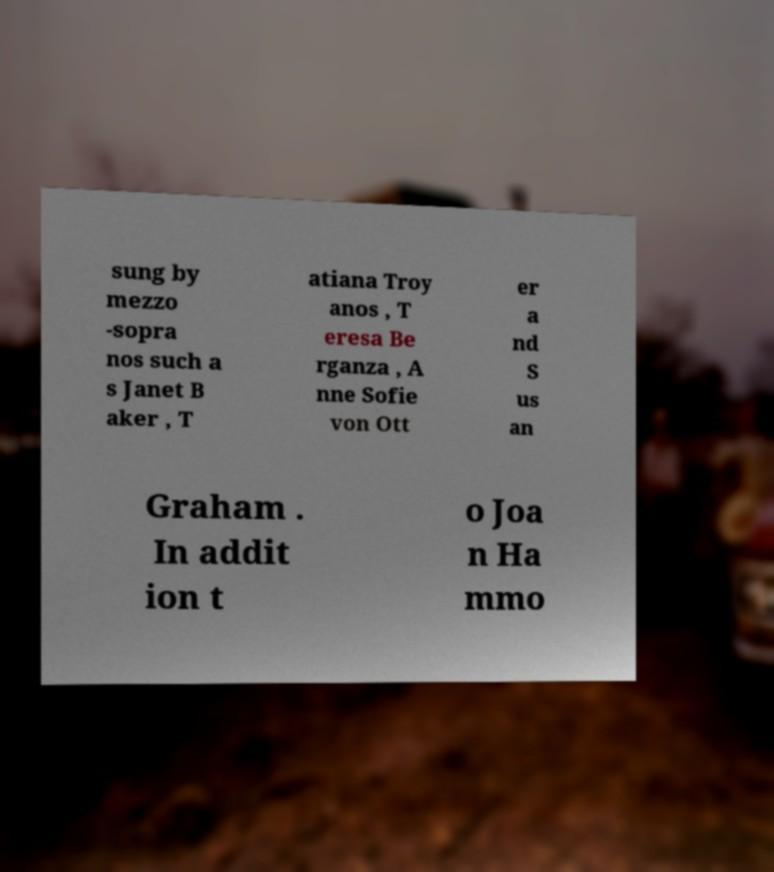I need the written content from this picture converted into text. Can you do that? sung by mezzo -sopra nos such a s Janet B aker , T atiana Troy anos , T eresa Be rganza , A nne Sofie von Ott er a nd S us an Graham . In addit ion t o Joa n Ha mmo 